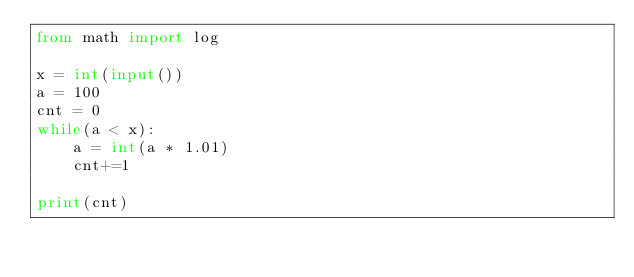Convert code to text. <code><loc_0><loc_0><loc_500><loc_500><_Python_>from math import log

x = int(input())
a = 100
cnt = 0
while(a < x):
    a = int(a * 1.01)
    cnt+=1

print(cnt)</code> 